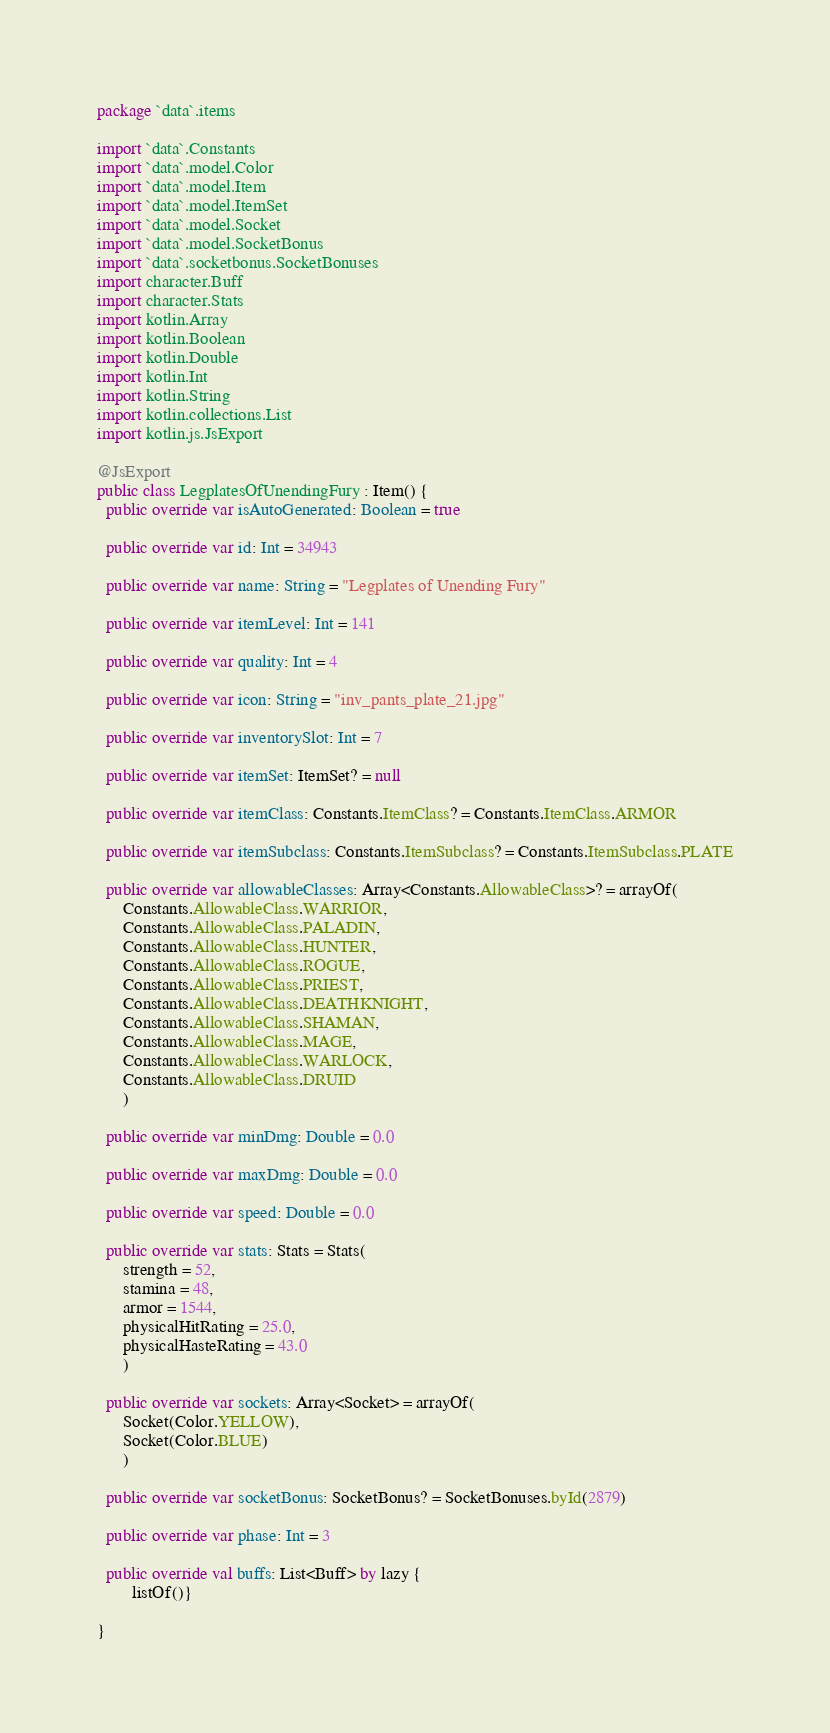<code> <loc_0><loc_0><loc_500><loc_500><_Kotlin_>package `data`.items

import `data`.Constants
import `data`.model.Color
import `data`.model.Item
import `data`.model.ItemSet
import `data`.model.Socket
import `data`.model.SocketBonus
import `data`.socketbonus.SocketBonuses
import character.Buff
import character.Stats
import kotlin.Array
import kotlin.Boolean
import kotlin.Double
import kotlin.Int
import kotlin.String
import kotlin.collections.List
import kotlin.js.JsExport

@JsExport
public class LegplatesOfUnendingFury : Item() {
  public override var isAutoGenerated: Boolean = true

  public override var id: Int = 34943

  public override var name: String = "Legplates of Unending Fury"

  public override var itemLevel: Int = 141

  public override var quality: Int = 4

  public override var icon: String = "inv_pants_plate_21.jpg"

  public override var inventorySlot: Int = 7

  public override var itemSet: ItemSet? = null

  public override var itemClass: Constants.ItemClass? = Constants.ItemClass.ARMOR

  public override var itemSubclass: Constants.ItemSubclass? = Constants.ItemSubclass.PLATE

  public override var allowableClasses: Array<Constants.AllowableClass>? = arrayOf(
      Constants.AllowableClass.WARRIOR,
      Constants.AllowableClass.PALADIN,
      Constants.AllowableClass.HUNTER,
      Constants.AllowableClass.ROGUE,
      Constants.AllowableClass.PRIEST,
      Constants.AllowableClass.DEATHKNIGHT,
      Constants.AllowableClass.SHAMAN,
      Constants.AllowableClass.MAGE,
      Constants.AllowableClass.WARLOCK,
      Constants.AllowableClass.DRUID
      )

  public override var minDmg: Double = 0.0

  public override var maxDmg: Double = 0.0

  public override var speed: Double = 0.0

  public override var stats: Stats = Stats(
      strength = 52,
      stamina = 48,
      armor = 1544,
      physicalHitRating = 25.0,
      physicalHasteRating = 43.0
      )

  public override var sockets: Array<Socket> = arrayOf(
      Socket(Color.YELLOW),
      Socket(Color.BLUE)
      )

  public override var socketBonus: SocketBonus? = SocketBonuses.byId(2879)

  public override var phase: Int = 3

  public override val buffs: List<Buff> by lazy {
        listOf()}

}
</code> 